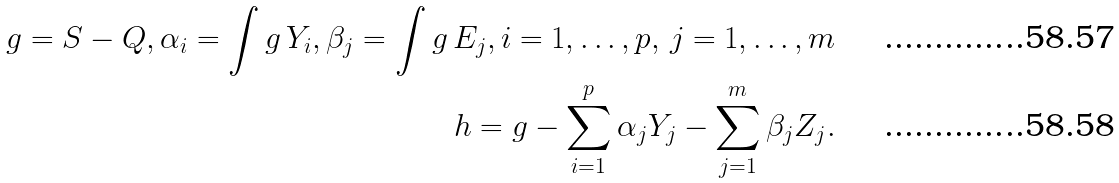<formula> <loc_0><loc_0><loc_500><loc_500>g = S - Q , \alpha _ { i } = \int g \, Y _ { i } , \beta _ { j } = \int g \, E _ { j } , i = 1 , \dots , p , \, j = 1 , \dots , m \\ h = g - \sum _ { i = 1 } ^ { p } \alpha _ { j } Y _ { j } - \sum _ { j = 1 } ^ { m } \beta _ { j } Z _ { j } .</formula> 